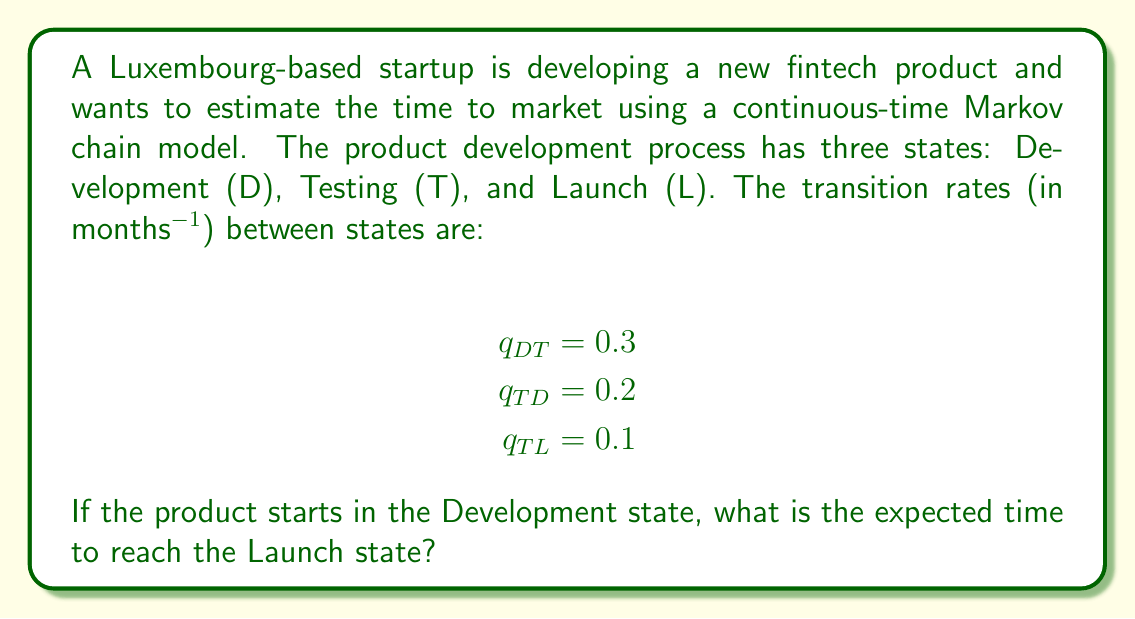Solve this math problem. To solve this problem, we'll use the theory of absorbing Markov chains, as the Launch state is an absorbing state.

Step 1: Set up the transition rate matrix Q.
$$Q = \begin{bmatrix}
-0.3 & 0.3 & 0 \\
0.2 & -0.3 & 0.1 \\
0 & 0 & 0
\end{bmatrix}$$

Step 2: Identify the transient states (D and T) and absorbing state (L).

Step 3: Extract the submatrix Q' containing only the transient states.
$$Q' = \begin{bmatrix}
-0.3 & 0.3 \\
0.2 & -0.3
\end{bmatrix}$$

Step 4: Calculate the fundamental matrix N = -Q'^(-1).
$$\begin{align*}
N &= -\begin{bmatrix}
-0.3 & 0.3 \\
0.2 & -0.3
\end{bmatrix}^{-1} \\
&= \frac{1}{0.09 - 0.06}\begin{bmatrix}
0.3 & 0.3 \\
0.2 & 0.3
\end{bmatrix} \\
&= \begin{bmatrix}
10 & 10 \\
6.67 & 10
\end{bmatrix}
\end{align*}$$

Step 5: The expected time to absorption (Launch) from the Development state is the sum of the first row of N.
$$E[T_{DL}] = 10 + 10 = 20$$

Therefore, the expected time to reach the Launch state from the Development state is 20 months.
Answer: 20 months 